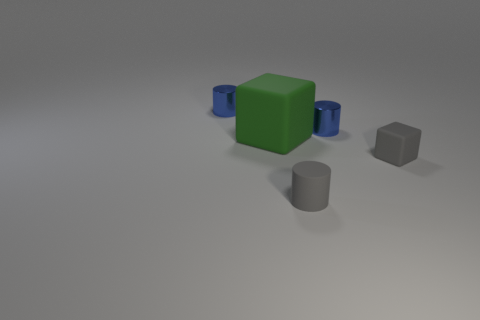Does the rubber cube that is right of the green rubber block have the same size as the big green thing?
Give a very brief answer. No. What number of metal cylinders are the same size as the gray matte cylinder?
Offer a very short reply. 2. What is the size of the object that is the same color as the small matte cylinder?
Ensure brevity in your answer.  Small. Does the tiny matte cylinder have the same color as the small matte block?
Your response must be concise. Yes. The big green matte thing is what shape?
Your response must be concise. Cube. Are there any large matte blocks that have the same color as the small matte block?
Make the answer very short. No. Is the number of blue metal objects on the left side of the small gray cylinder greater than the number of tiny red metallic cylinders?
Provide a succinct answer. Yes. Is the shape of the big thing the same as the small blue thing on the left side of the big block?
Keep it short and to the point. No. Is there a matte block?
Provide a short and direct response. Yes. How many small things are green cubes or gray rubber cylinders?
Offer a terse response. 1. 